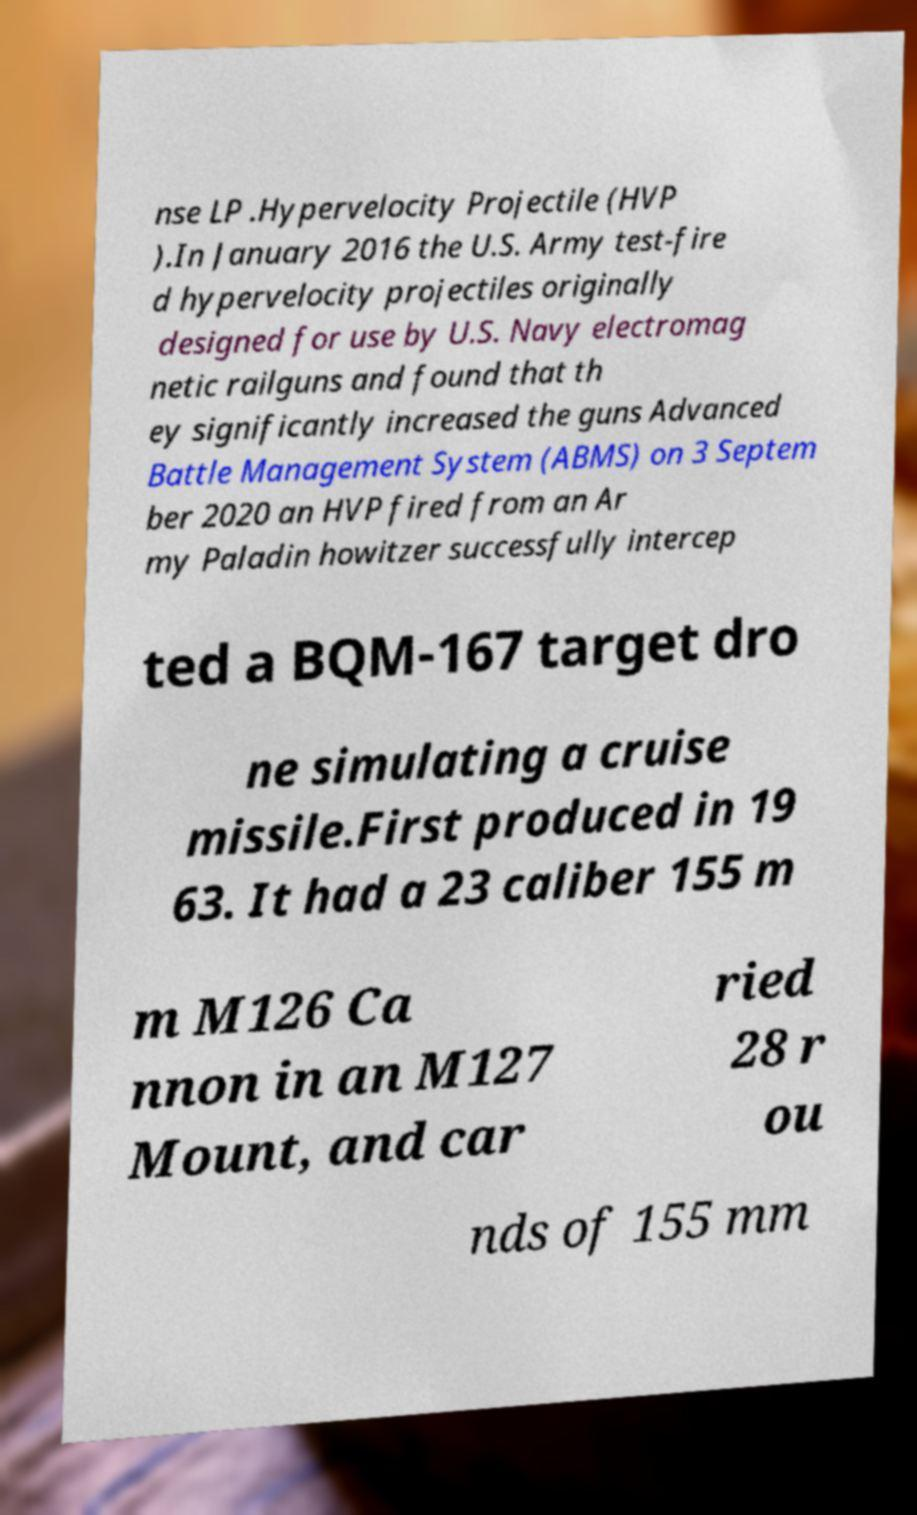I need the written content from this picture converted into text. Can you do that? nse LP .Hypervelocity Projectile (HVP ).In January 2016 the U.S. Army test-fire d hypervelocity projectiles originally designed for use by U.S. Navy electromag netic railguns and found that th ey significantly increased the guns Advanced Battle Management System (ABMS) on 3 Septem ber 2020 an HVP fired from an Ar my Paladin howitzer successfully intercep ted a BQM-167 target dro ne simulating a cruise missile.First produced in 19 63. It had a 23 caliber 155 m m M126 Ca nnon in an M127 Mount, and car ried 28 r ou nds of 155 mm 